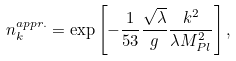Convert formula to latex. <formula><loc_0><loc_0><loc_500><loc_500>n _ { k } ^ { a p p r . } = \exp \left [ - \frac { 1 } { 5 3 } \frac { \sqrt { \lambda } } { g } \frac { k ^ { 2 } } { \lambda M _ { P l } ^ { 2 } } \right ] ,</formula> 